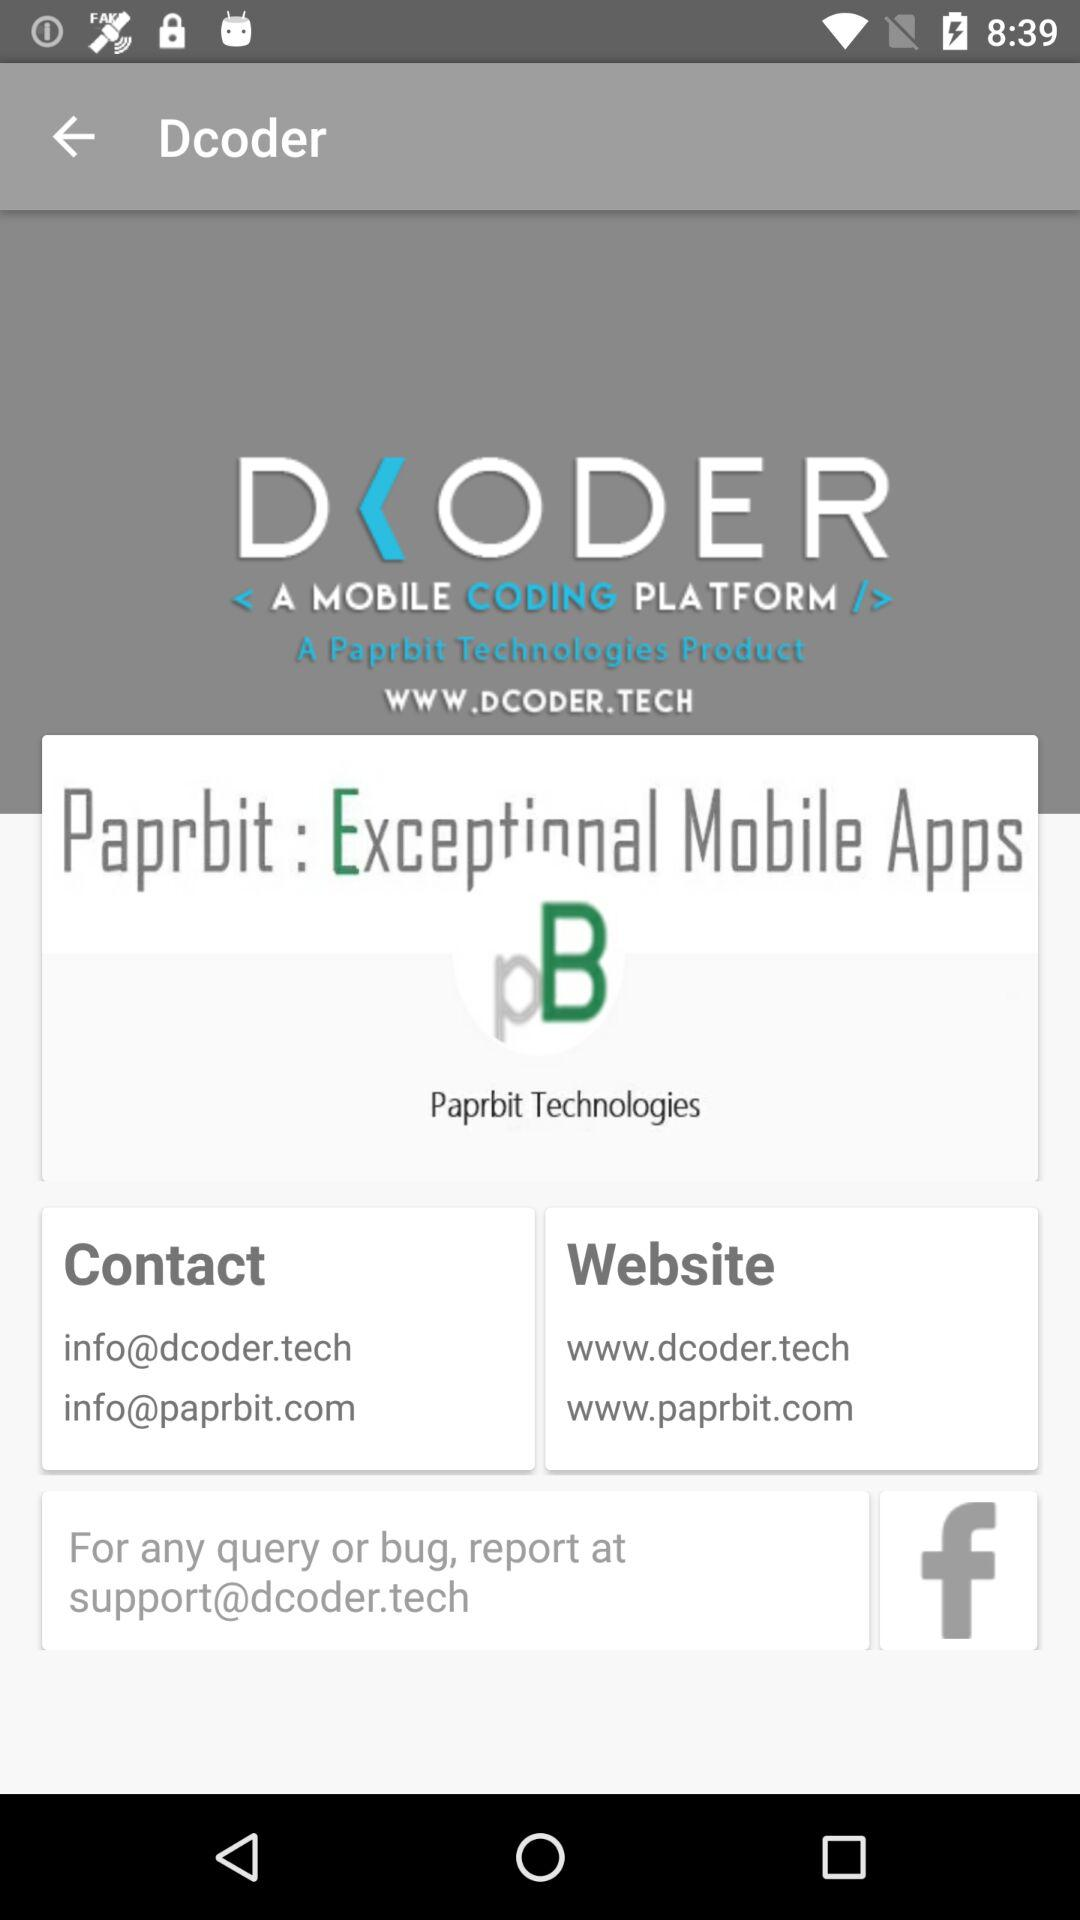What is the website address? The website addresses are www.dcoder.tech and www.paprbit.com. 